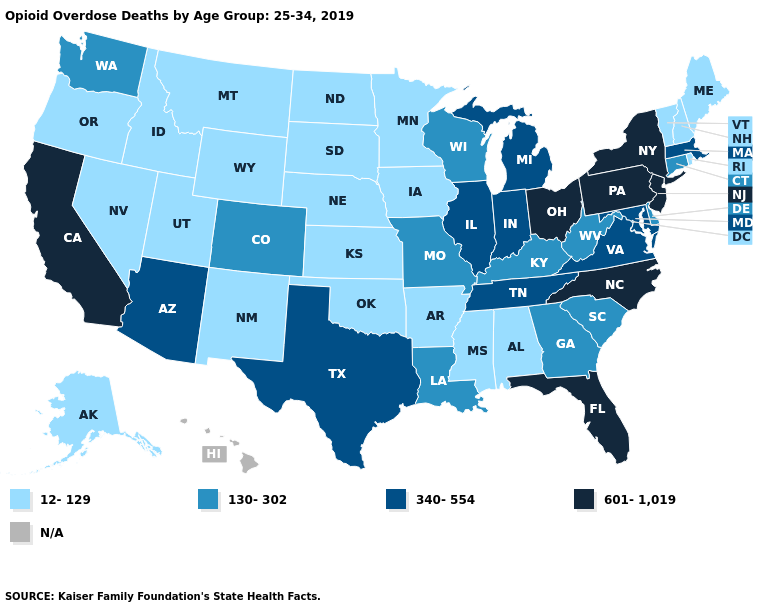Which states have the lowest value in the South?
Concise answer only. Alabama, Arkansas, Mississippi, Oklahoma. What is the value of Illinois?
Concise answer only. 340-554. Name the states that have a value in the range 12-129?
Keep it brief. Alabama, Alaska, Arkansas, Idaho, Iowa, Kansas, Maine, Minnesota, Mississippi, Montana, Nebraska, Nevada, New Hampshire, New Mexico, North Dakota, Oklahoma, Oregon, Rhode Island, South Dakota, Utah, Vermont, Wyoming. What is the highest value in the South ?
Quick response, please. 601-1,019. Among the states that border Pennsylvania , does West Virginia have the lowest value?
Keep it brief. Yes. What is the value of North Carolina?
Answer briefly. 601-1,019. What is the value of Georgia?
Answer briefly. 130-302. What is the highest value in states that border Michigan?
Write a very short answer. 601-1,019. What is the highest value in the Northeast ?
Be succinct. 601-1,019. Name the states that have a value in the range 340-554?
Concise answer only. Arizona, Illinois, Indiana, Maryland, Massachusetts, Michigan, Tennessee, Texas, Virginia. Does the first symbol in the legend represent the smallest category?
Keep it brief. Yes. What is the lowest value in the MidWest?
Give a very brief answer. 12-129. Does Ohio have the highest value in the MidWest?
Give a very brief answer. Yes. Does Texas have the lowest value in the USA?
Give a very brief answer. No. What is the highest value in the USA?
Write a very short answer. 601-1,019. 